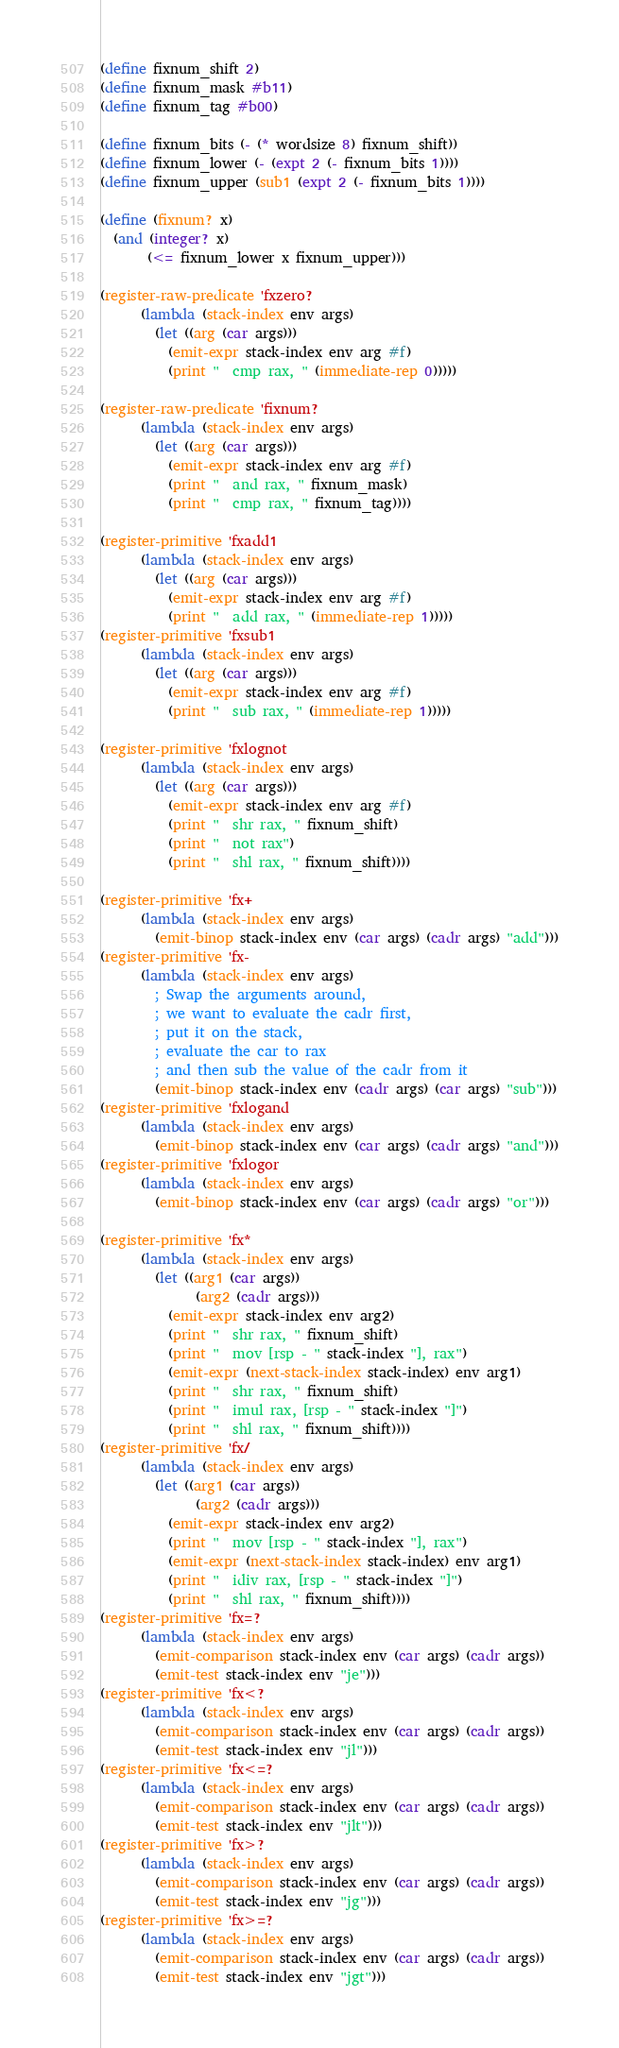<code> <loc_0><loc_0><loc_500><loc_500><_Scheme_>(define fixnum_shift 2)
(define fixnum_mask #b11)
(define fixnum_tag #b00)

(define fixnum_bits (- (* wordsize 8) fixnum_shift))
(define fixnum_lower (- (expt 2 (- fixnum_bits 1))))
(define fixnum_upper (sub1 (expt 2 (- fixnum_bits 1))))

(define (fixnum? x)
  (and (integer? x)
       (<= fixnum_lower x fixnum_upper)))

(register-raw-predicate 'fxzero?
      (lambda (stack-index env args)
        (let ((arg (car args)))
          (emit-expr stack-index env arg #f)
          (print "  cmp rax, " (immediate-rep 0)))))

(register-raw-predicate 'fixnum?
      (lambda (stack-index env args)
        (let ((arg (car args)))
          (emit-expr stack-index env arg #f)
          (print "  and rax, " fixnum_mask)
          (print "  cmp rax, " fixnum_tag))))

(register-primitive 'fxadd1
      (lambda (stack-index env args)
        (let ((arg (car args)))
          (emit-expr stack-index env arg #f)
          (print "  add rax, " (immediate-rep 1)))))
(register-primitive 'fxsub1
      (lambda (stack-index env args)
        (let ((arg (car args)))
          (emit-expr stack-index env arg #f)
          (print "  sub rax, " (immediate-rep 1)))))

(register-primitive 'fxlognot
      (lambda (stack-index env args)
        (let ((arg (car args)))
          (emit-expr stack-index env arg #f)
          (print "  shr rax, " fixnum_shift)
          (print "  not rax")
          (print "  shl rax, " fixnum_shift))))

(register-primitive 'fx+
      (lambda (stack-index env args)
        (emit-binop stack-index env (car args) (cadr args) "add")))
(register-primitive 'fx-
      (lambda (stack-index env args)
        ; Swap the arguments around,
        ; we want to evaluate the cadr first,
        ; put it on the stack,
        ; evaluate the car to rax
        ; and then sub the value of the cadr from it
        (emit-binop stack-index env (cadr args) (car args) "sub")))
(register-primitive 'fxlogand
      (lambda (stack-index env args)
        (emit-binop stack-index env (car args) (cadr args) "and")))
(register-primitive 'fxlogor
      (lambda (stack-index env args)
        (emit-binop stack-index env (car args) (cadr args) "or")))

(register-primitive 'fx*
      (lambda (stack-index env args)
        (let ((arg1 (car args))
              (arg2 (cadr args)))
          (emit-expr stack-index env arg2)
          (print "  shr rax, " fixnum_shift)
          (print "  mov [rsp - " stack-index "], rax")
          (emit-expr (next-stack-index stack-index) env arg1)
          (print "  shr rax, " fixnum_shift)
          (print "  imul rax, [rsp - " stack-index "]")
          (print "  shl rax, " fixnum_shift))))
(register-primitive 'fx/
      (lambda (stack-index env args)
        (let ((arg1 (car args))
              (arg2 (cadr args)))
          (emit-expr stack-index env arg2)
          (print "  mov [rsp - " stack-index "], rax")
          (emit-expr (next-stack-index stack-index) env arg1)
          (print "  idiv rax, [rsp - " stack-index "]")
          (print "  shl rax, " fixnum_shift))))
(register-primitive 'fx=?
      (lambda (stack-index env args)
        (emit-comparison stack-index env (car args) (cadr args))
        (emit-test stack-index env "je")))
(register-primitive 'fx<?
      (lambda (stack-index env args)
        (emit-comparison stack-index env (car args) (cadr args))
        (emit-test stack-index env "jl")))
(register-primitive 'fx<=?
      (lambda (stack-index env args)
        (emit-comparison stack-index env (car args) (cadr args))
        (emit-test stack-index env "jlt")))
(register-primitive 'fx>?
      (lambda (stack-index env args)
        (emit-comparison stack-index env (car args) (cadr args))
        (emit-test stack-index env "jg")))
(register-primitive 'fx>=?
      (lambda (stack-index env args)
        (emit-comparison stack-index env (car args) (cadr args))
        (emit-test stack-index env "jgt")))
</code> 